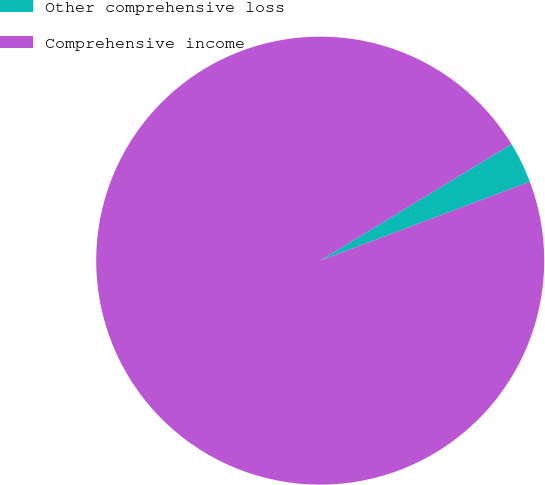<chart> <loc_0><loc_0><loc_500><loc_500><pie_chart><fcel>Other comprehensive loss<fcel>Comprehensive income<nl><fcel>2.98%<fcel>97.02%<nl></chart> 